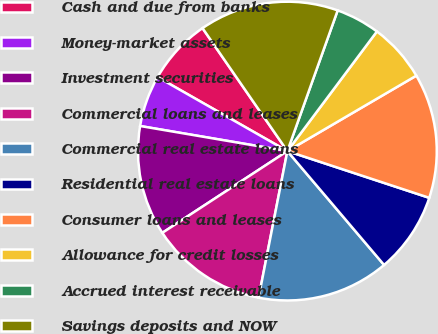<chart> <loc_0><loc_0><loc_500><loc_500><pie_chart><fcel>Cash and due from banks<fcel>Money-market assets<fcel>Investment securities<fcel>Commercial loans and leases<fcel>Commercial real estate loans<fcel>Residential real estate loans<fcel>Consumer loans and leases<fcel>Allowance for credit losses<fcel>Accrued interest receivable<fcel>Savings deposits and NOW<nl><fcel>7.14%<fcel>5.56%<fcel>11.9%<fcel>12.7%<fcel>14.29%<fcel>8.73%<fcel>13.49%<fcel>6.35%<fcel>4.76%<fcel>15.08%<nl></chart> 